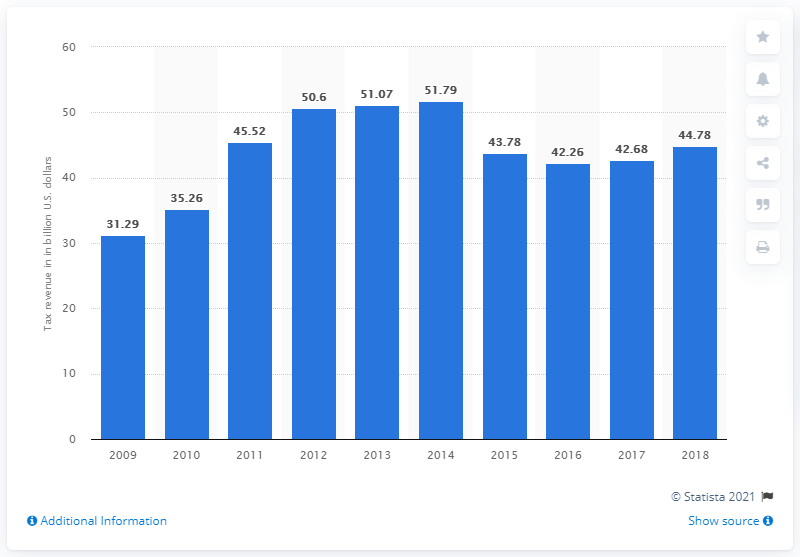Specify some key components in this picture. In 2018, Malaysia's tax revenue was 44.78 billion. 